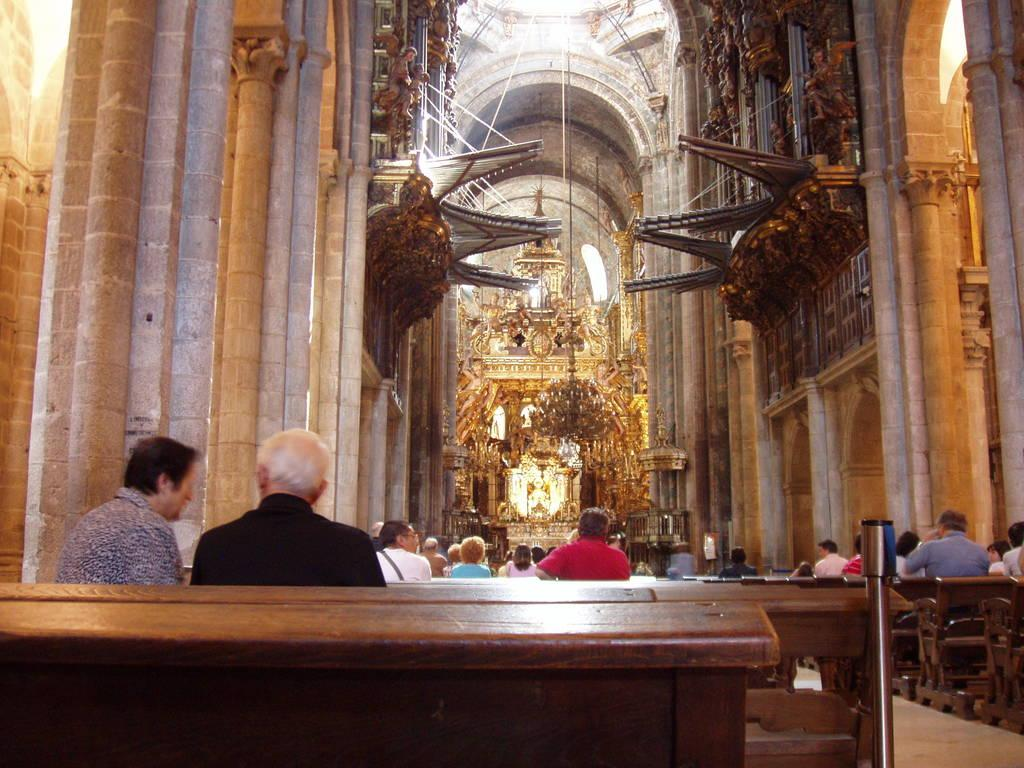What type of location is depicted in the image? The image shows an inside view of a building. What are the people in the image doing? The people in the image are sitting on benches. What type of lighting fixture can be seen in the background of the image? There is a chandelier visible in the background of the image. Can you see any chickens or lizards in the image? No, there are no chickens or lizards present in the image. 